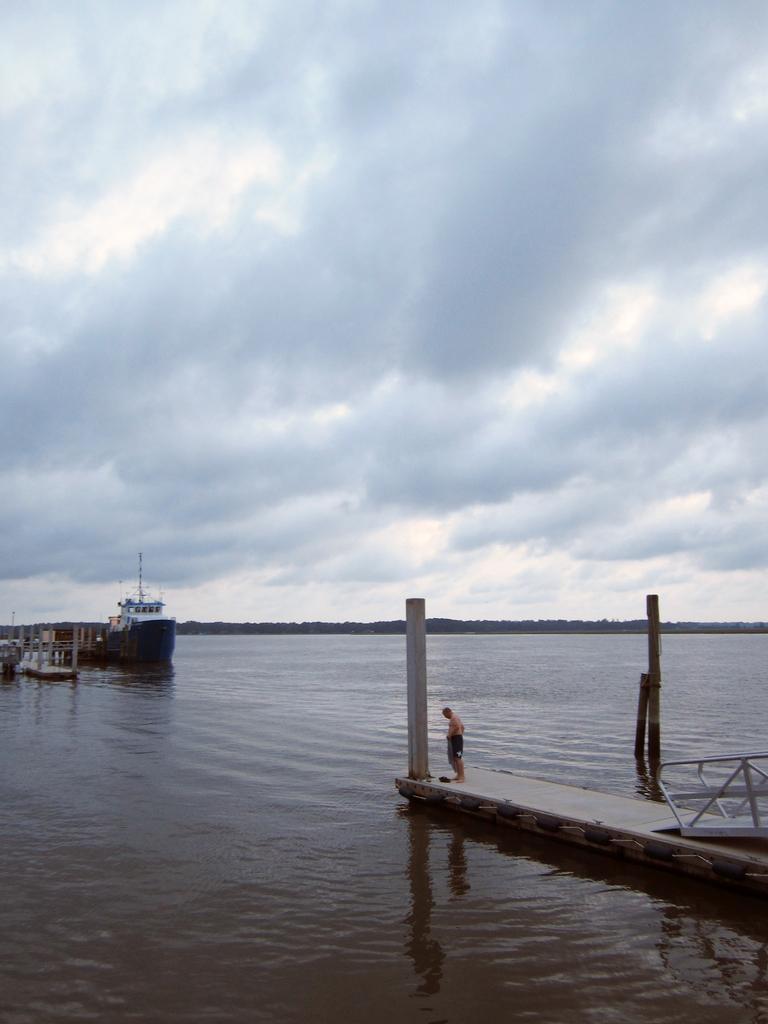Could you give a brief overview of what you see in this image? In this image there are ships on the river and there is a person standing on the path which is made up of wood, beside the person there is a pole and there is a metal structure. In the background there is the sky. 